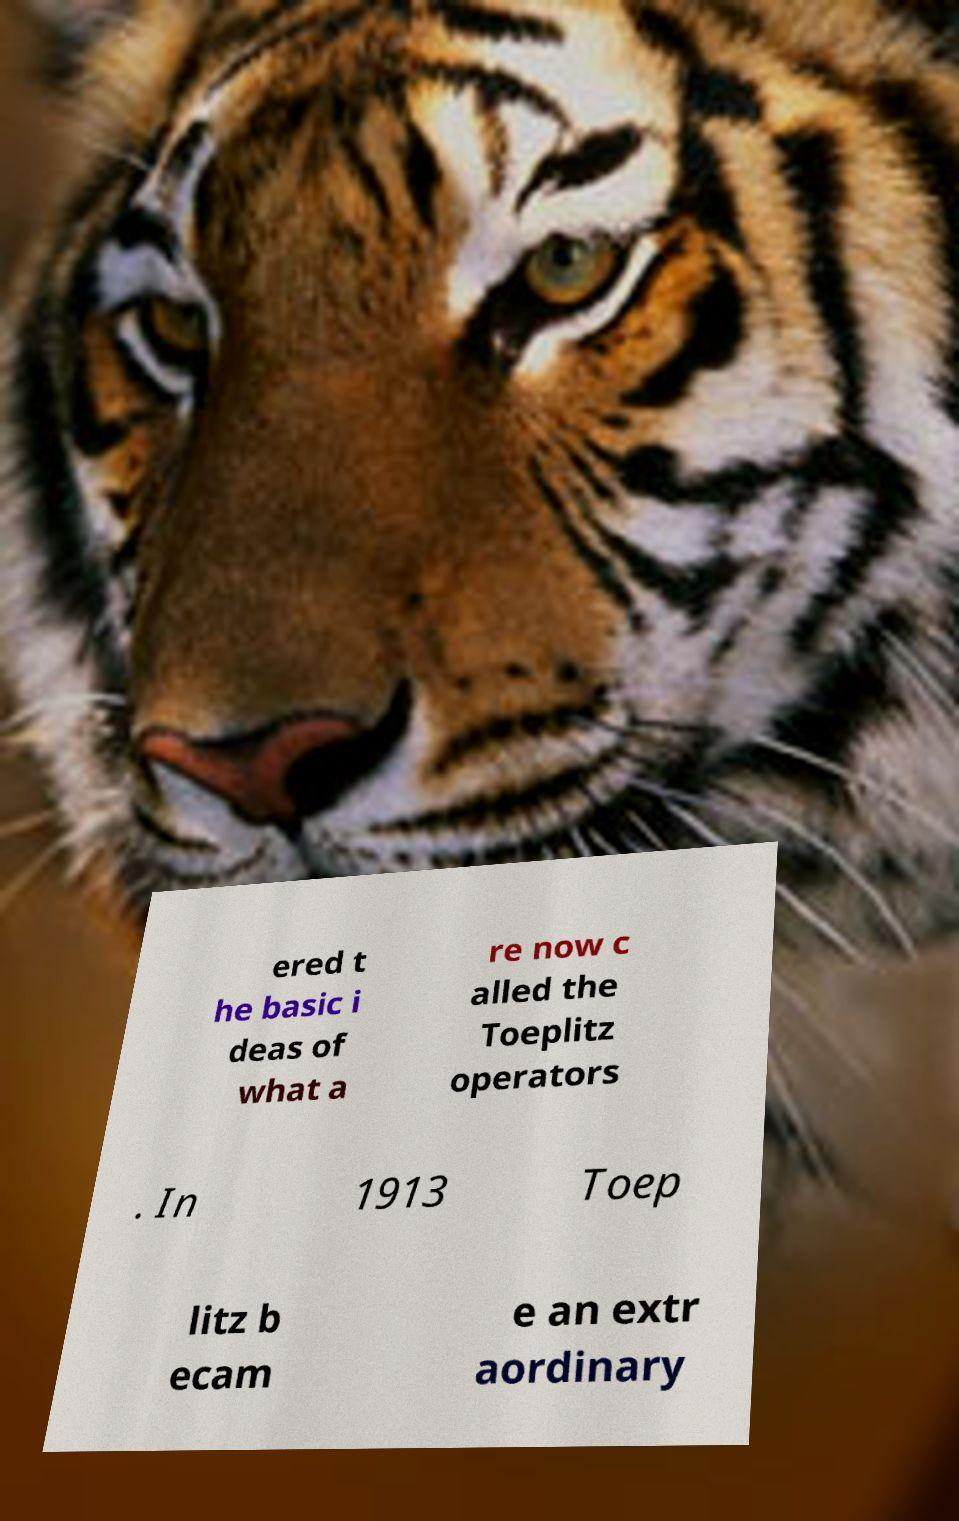Could you assist in decoding the text presented in this image and type it out clearly? ered t he basic i deas of what a re now c alled the Toeplitz operators . In 1913 Toep litz b ecam e an extr aordinary 